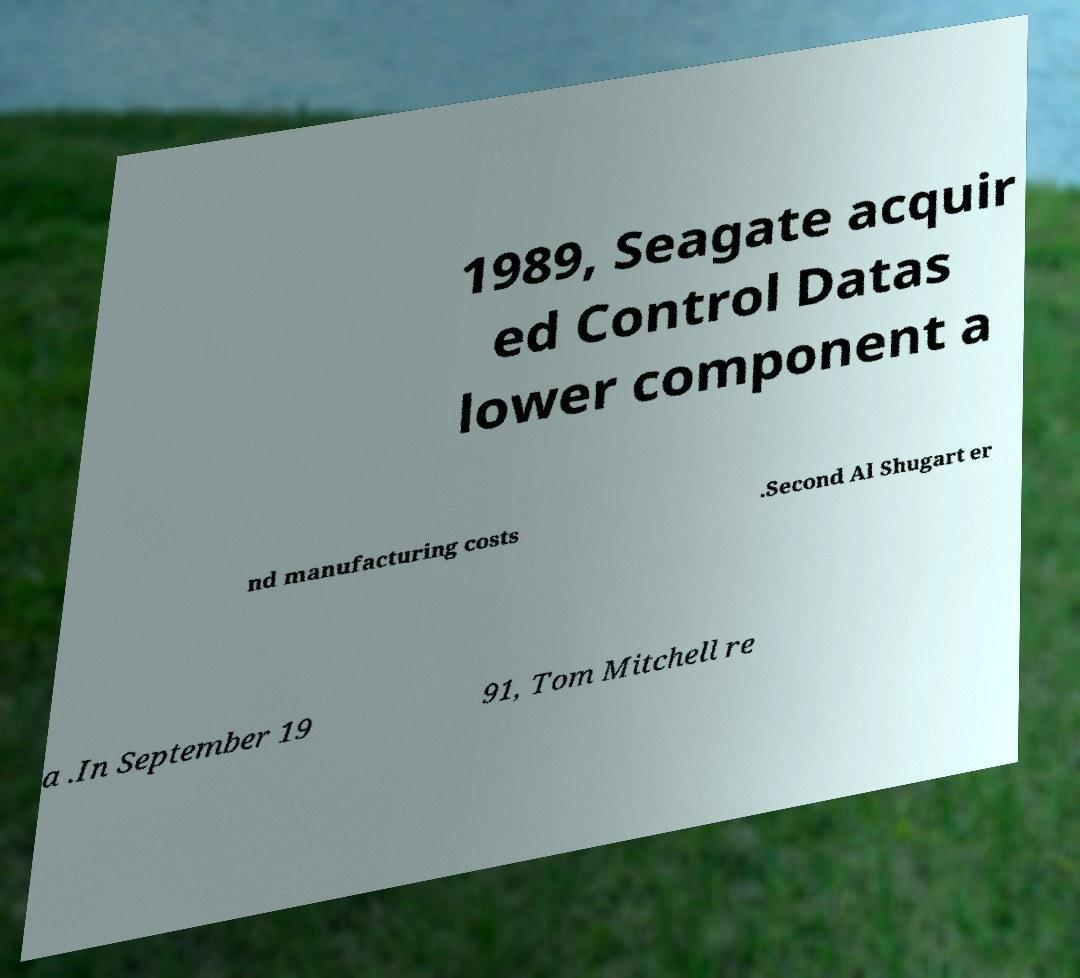Can you accurately transcribe the text from the provided image for me? 1989, Seagate acquir ed Control Datas lower component a nd manufacturing costs .Second Al Shugart er a .In September 19 91, Tom Mitchell re 